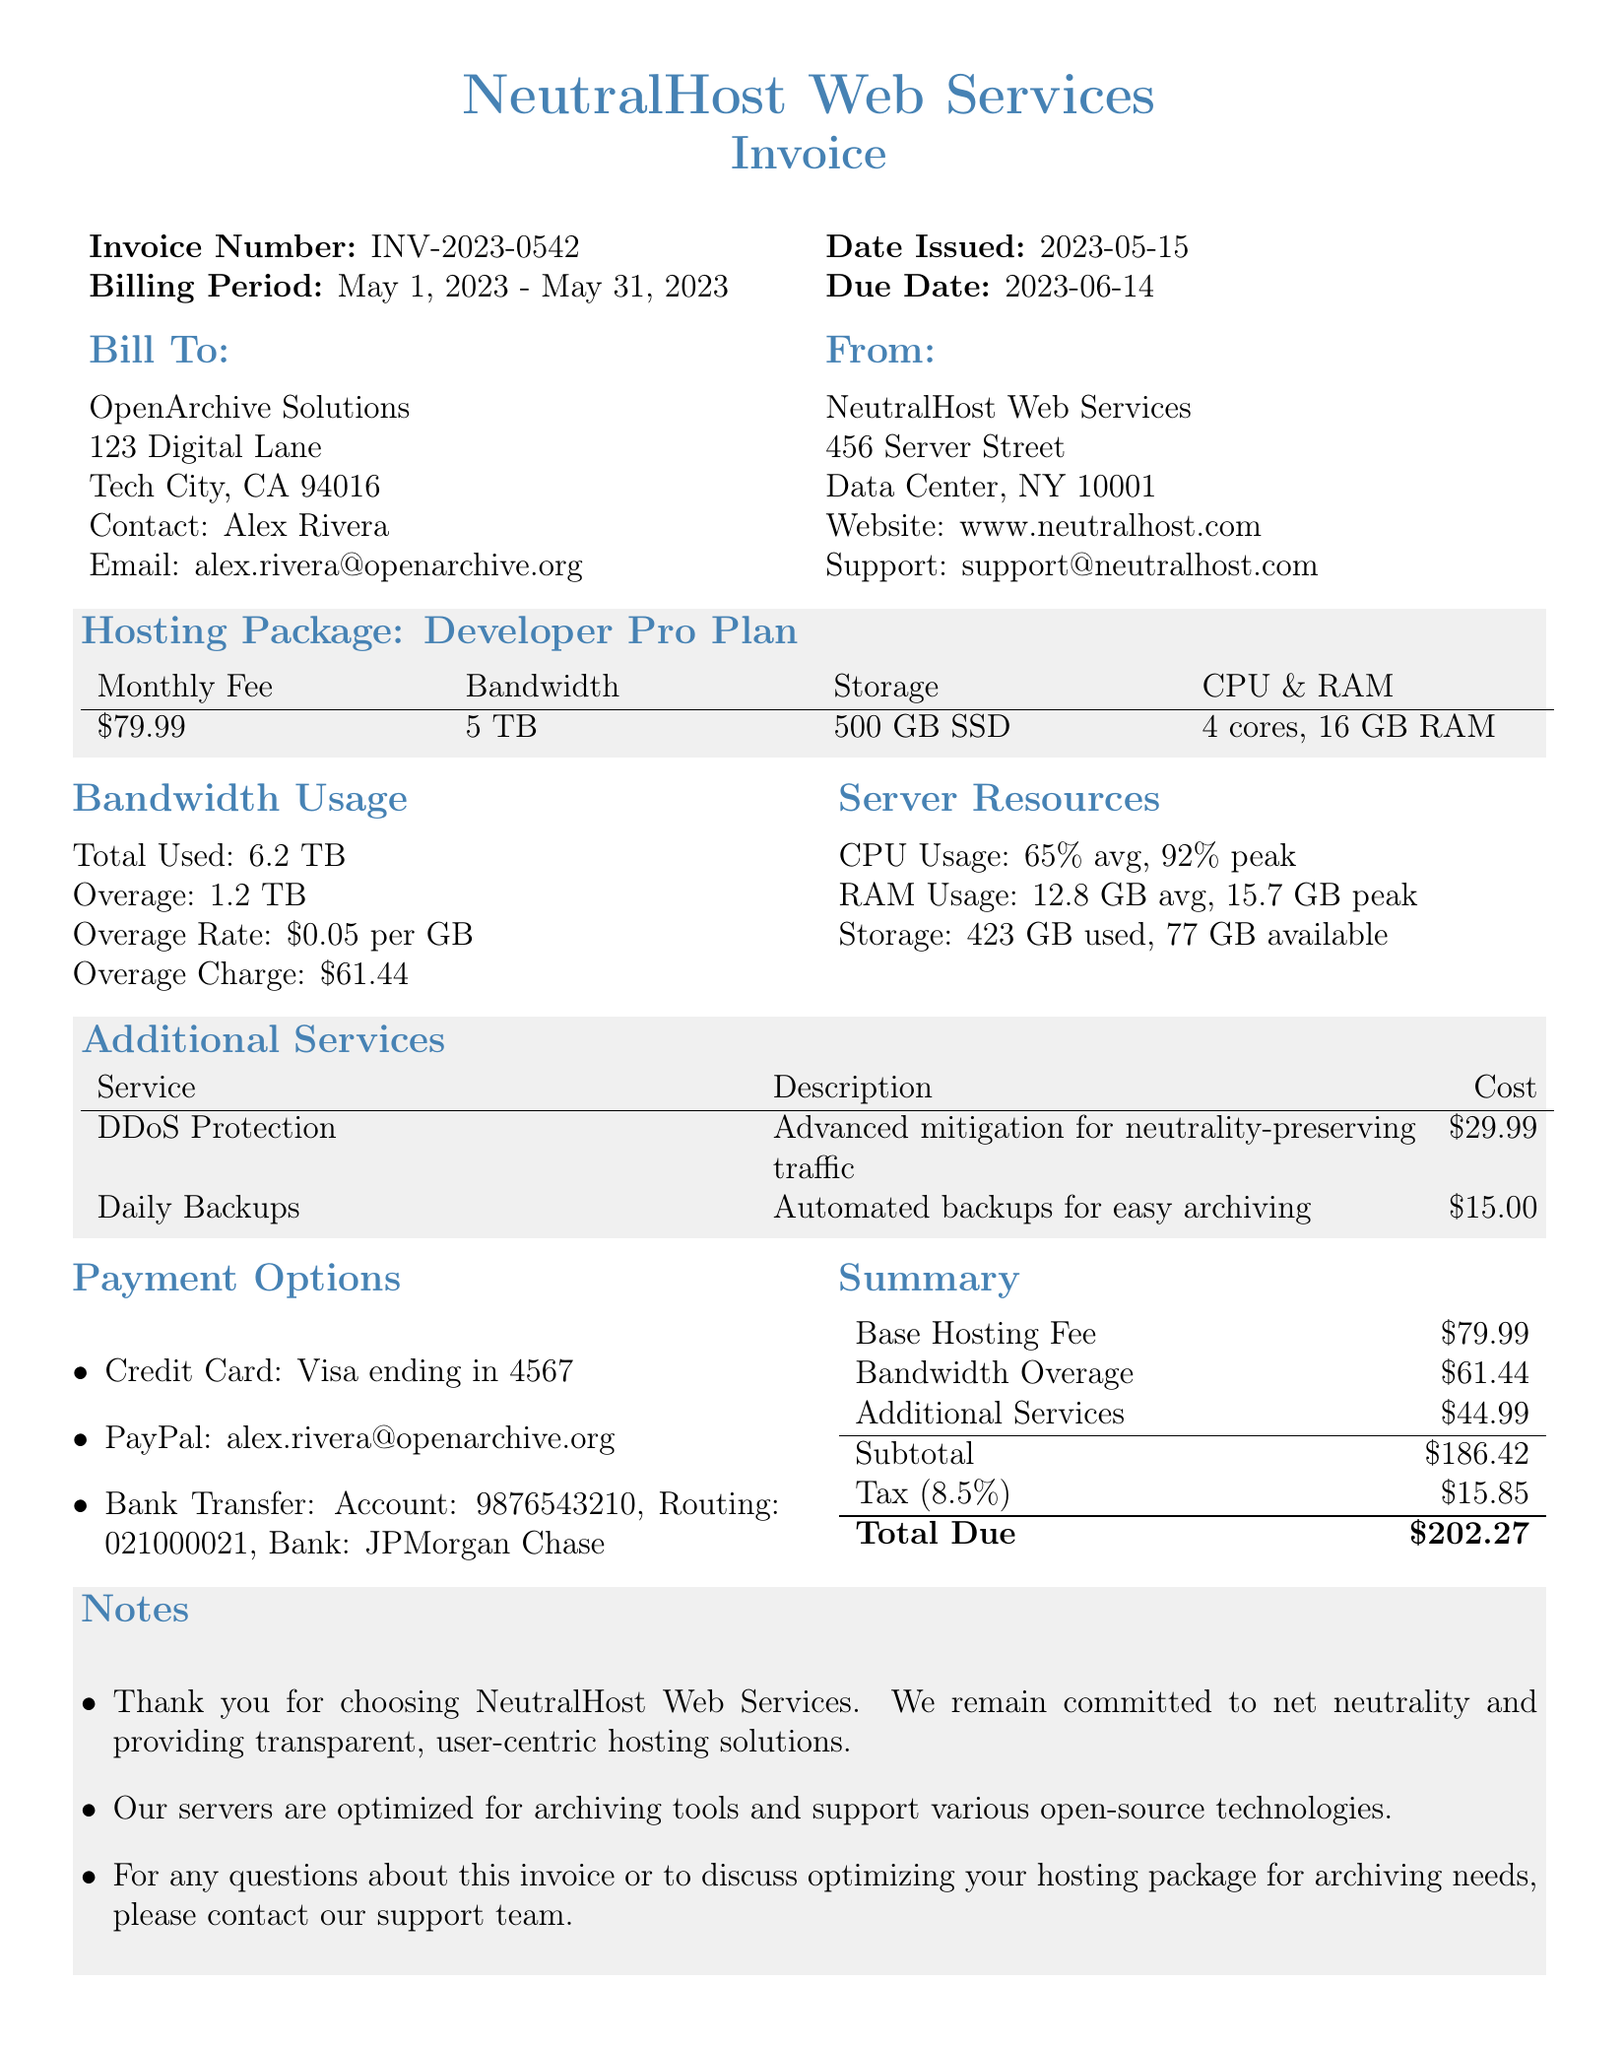what is the invoice number? The invoice number is a unique identifier for the transaction, stated as INV-2023-0542.
Answer: INV-2023-0542 what is the total amount due? The total amount due is the final billing amount for the services provided, which includes hosting fees, overage charges, and taxes.
Answer: 202.27 what is the overage charge? The overage charge refers to the extra cost incurred when exceeding the included bandwidth limit, calculated from the total used bandwidth.
Answer: 61.44 who is the contact person for the client? The contact person is the representative of the client organization referenced in the document, providing their name for communication purposes.
Answer: Alex Rivera what is the average CPU usage? The average CPU usage indicates what percentage of CPU resources was used on average during the billing period.
Answer: 65% how many additional services are listed? This question identifies the number of services that are offered in addition to the main hosting package, each with its own specific features and costs.
Answer: 2 what is the included storage amount? The included storage amount represents the total storage space that is provided within the hosting package without additional charges.
Answer: 500 GB SSD what is the tax rate applied to the invoice? The tax rate is the percentage applied to the subtotal to calculate the tax amount that needs to be paid.
Answer: 0.085 what is the description of DDoS Protection? This description provides information about the specific additional service offered, highlighting its purpose and function.
Answer: Advanced mitigation for neutrality-preserving traffic 